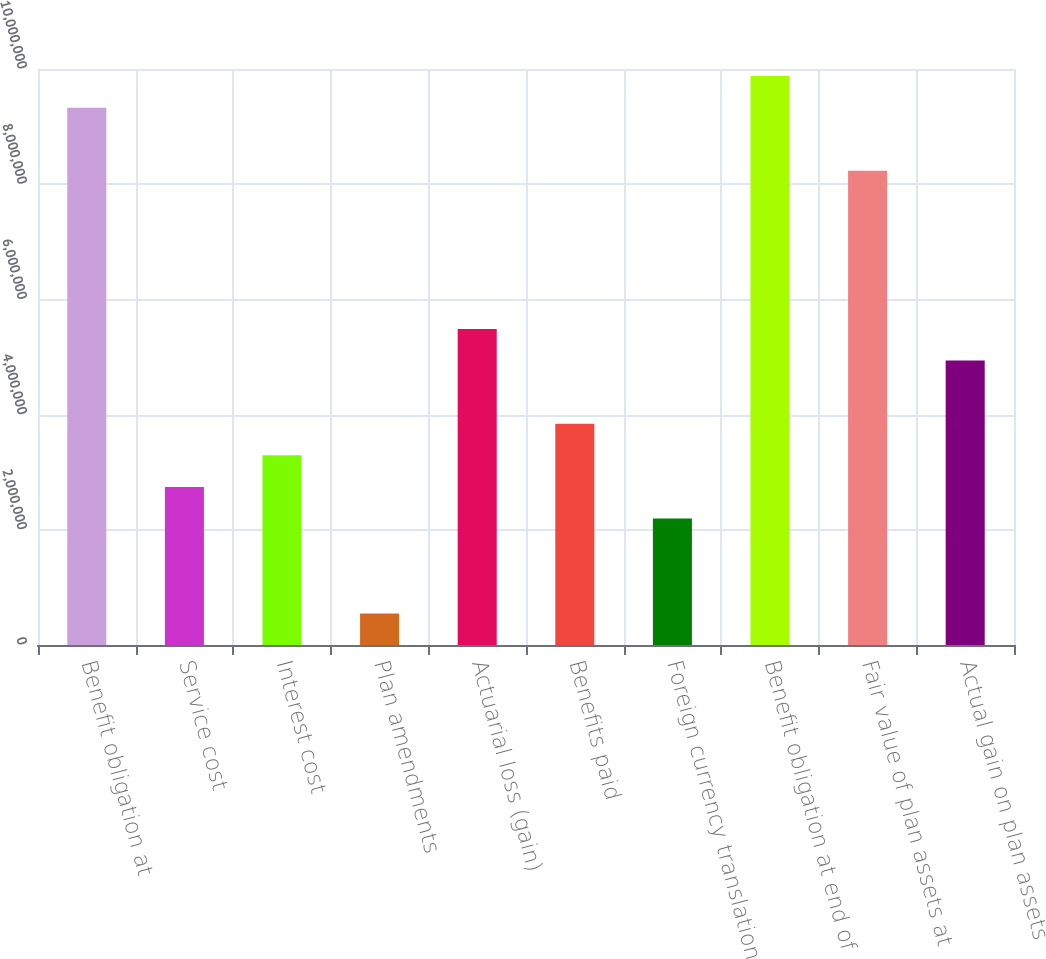Convert chart. <chart><loc_0><loc_0><loc_500><loc_500><bar_chart><fcel>Benefit obligation at<fcel>Service cost<fcel>Interest cost<fcel>Plan amendments<fcel>Actuarial loss (gain)<fcel>Benefits paid<fcel>Foreign currency translation<fcel>Benefit obligation at end of<fcel>Fair value of plan assets at<fcel>Actual gain on plan assets<nl><fcel>9.32884e+06<fcel>2.74381e+06<fcel>3.29256e+06<fcel>548797<fcel>5.48757e+06<fcel>3.84132e+06<fcel>2.19506e+06<fcel>9.8776e+06<fcel>8.23134e+06<fcel>4.93882e+06<nl></chart> 